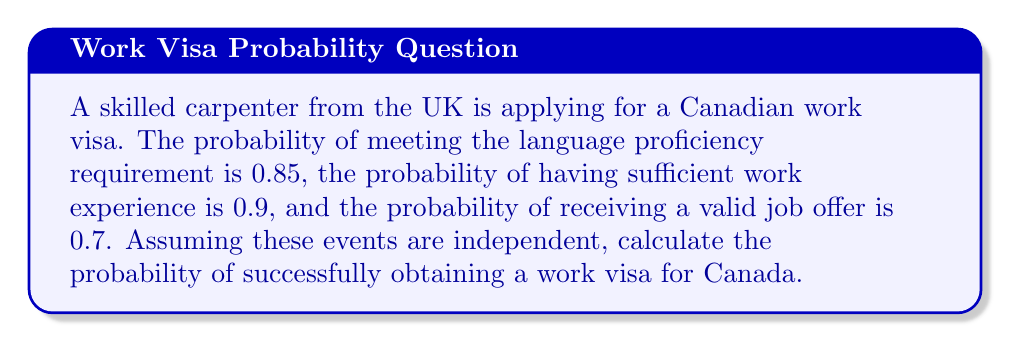Can you answer this question? Let's approach this step-by-step:

1) Define the events:
   A: Meeting language proficiency requirement
   B: Having sufficient work experience
   C: Receiving a valid job offer

2) Given probabilities:
   P(A) = 0.85
   P(B) = 0.9
   P(C) = 0.7

3) To successfully obtain a work visa, all three conditions must be met. Since the events are independent, we can multiply their individual probabilities:

   P(Successful visa) = P(A ∩ B ∩ C) = P(A) × P(B) × P(C)

4) Substituting the values:

   P(Successful visa) = 0.85 × 0.9 × 0.7

5) Calculate:
   
   P(Successful visa) = 0.5355

6) Convert to percentage:
   
   0.5355 × 100% = 53.55%

Therefore, the probability of successfully obtaining a work visa for Canada is approximately 53.55%.
Answer: $0.5355$ or $53.55\%$ 